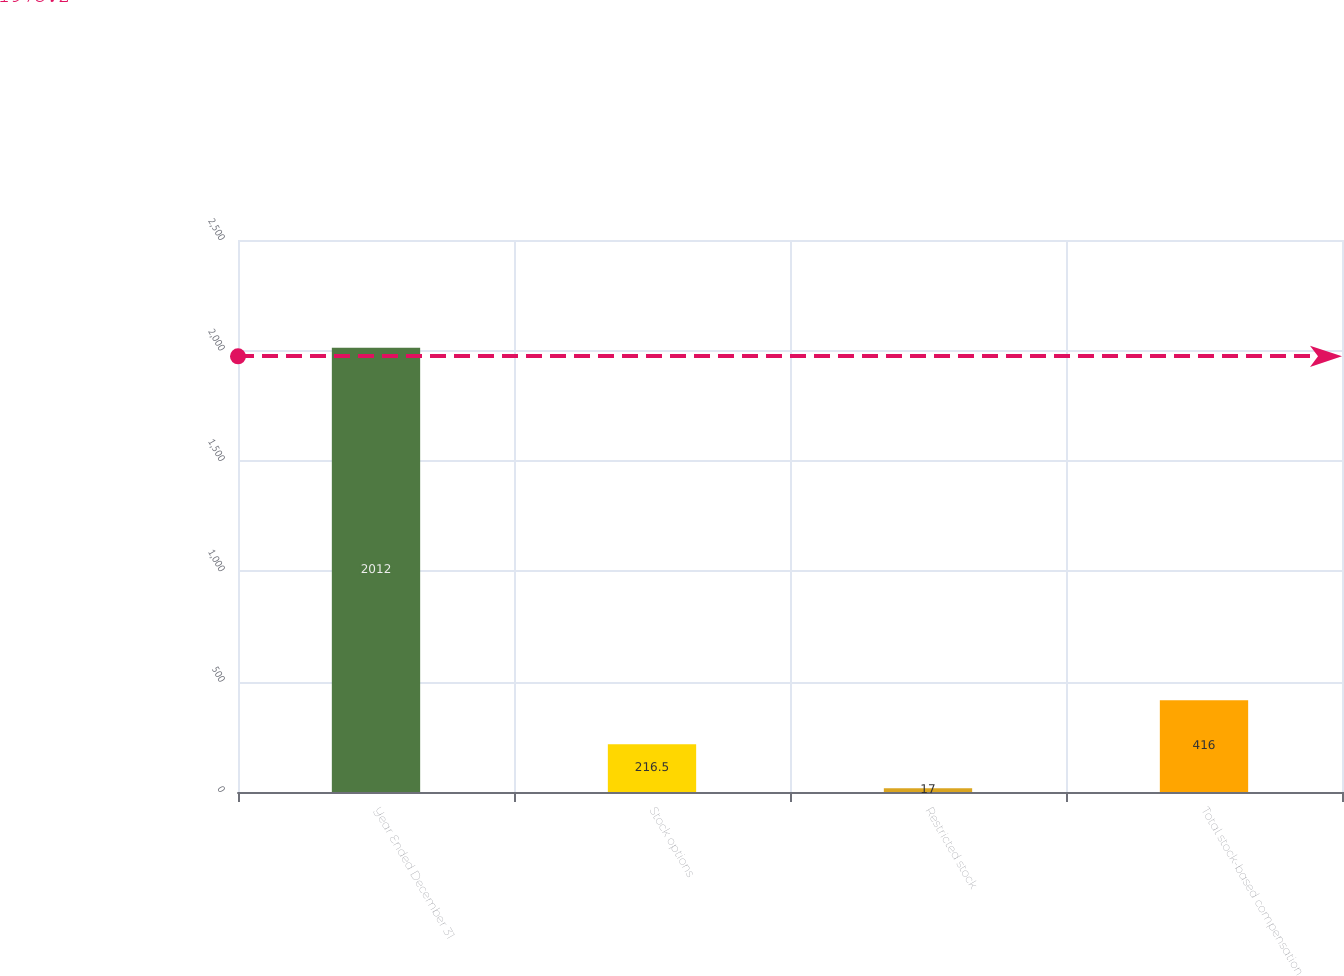Convert chart. <chart><loc_0><loc_0><loc_500><loc_500><bar_chart><fcel>Year Ended December 31<fcel>Stock options<fcel>Restricted stock<fcel>Total stock-based compensation<nl><fcel>2012<fcel>216.5<fcel>17<fcel>416<nl></chart> 